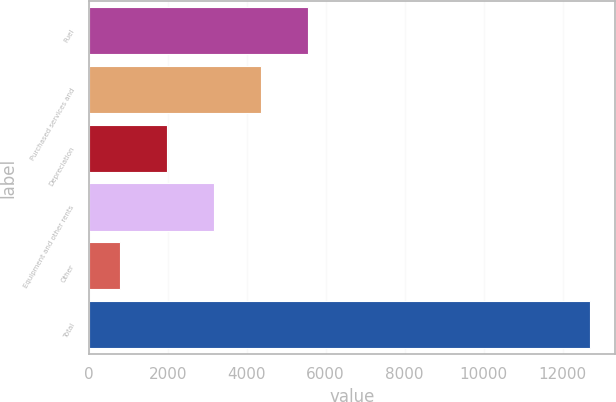<chart> <loc_0><loc_0><loc_500><loc_500><bar_chart><fcel>Fuel<fcel>Purchased services and<fcel>Depreciation<fcel>Equipment and other rents<fcel>Other<fcel>Total<nl><fcel>5558.8<fcel>4369.6<fcel>1991.2<fcel>3180.4<fcel>802<fcel>12694<nl></chart> 